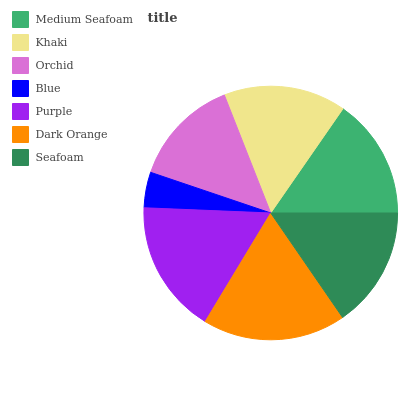Is Blue the minimum?
Answer yes or no. Yes. Is Dark Orange the maximum?
Answer yes or no. Yes. Is Khaki the minimum?
Answer yes or no. No. Is Khaki the maximum?
Answer yes or no. No. Is Khaki greater than Medium Seafoam?
Answer yes or no. Yes. Is Medium Seafoam less than Khaki?
Answer yes or no. Yes. Is Medium Seafoam greater than Khaki?
Answer yes or no. No. Is Khaki less than Medium Seafoam?
Answer yes or no. No. Is Seafoam the high median?
Answer yes or no. Yes. Is Seafoam the low median?
Answer yes or no. Yes. Is Khaki the high median?
Answer yes or no. No. Is Orchid the low median?
Answer yes or no. No. 